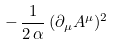<formula> <loc_0><loc_0><loc_500><loc_500>- \, \frac { 1 } { 2 \, \alpha } \, ( \partial _ { \mu } A ^ { \mu } ) ^ { 2 }</formula> 